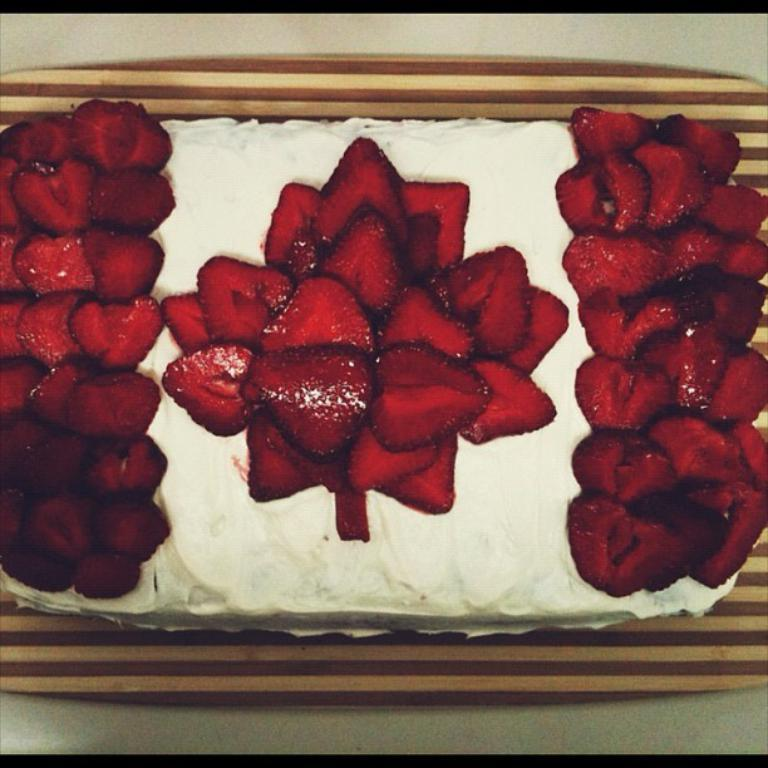What is the main subject of the image? There is a cake in the image. What decorations are on the cake? The cake is garnished with strawberries. Where is the cake placed in the image? The cake is on a platform. What type of nut is used to hold the candles on the cake? There are no candles or nuts mentioned in the image, as it only features a cake garnished with strawberries on a platform. 